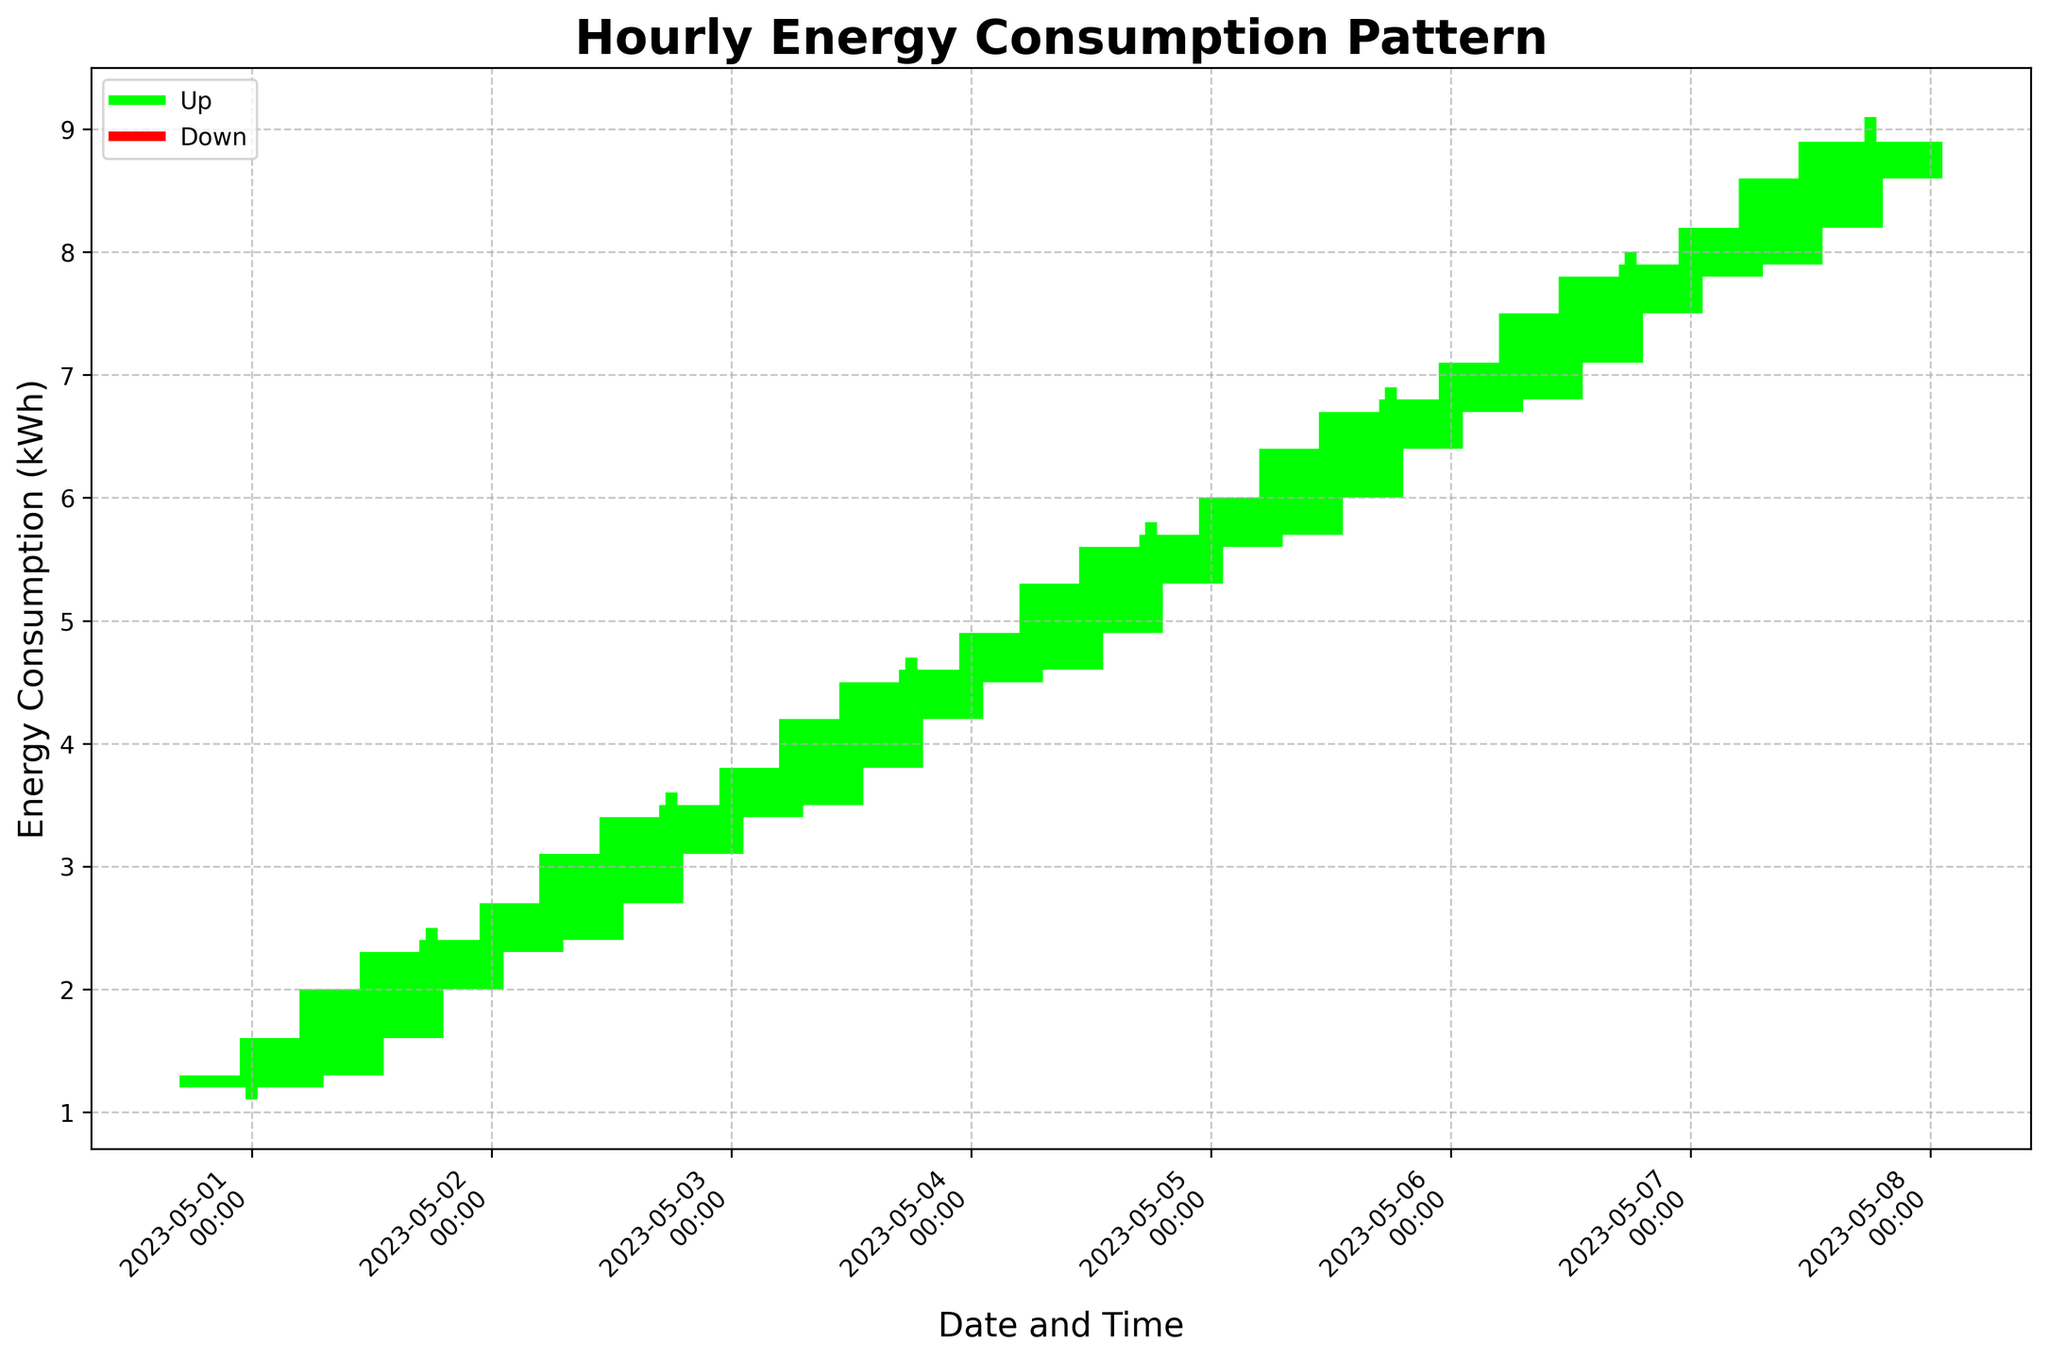What's the title of the figure? The title is usually located at the top of the plot. In this case, the title reads "Hourly Energy Consumption Pattern."
Answer: Hourly Energy Consumption Pattern What are the labels for the x-axis and y-axis? The x-axis label is located horizontally at the bottom beneath the x-axis, and the y-axis label is located vertically along the left side. For this figure, the x-axis is labeled "Date and Time," and the y-axis is labeled "Energy Consumption (kWh)."
Answer: Date and Time, Energy Consumption (kWh) Which color represents an upward trend in energy consumption? The plot uses green bars to indicate periods where the energy consumption closed higher than it opened.
Answer: Green On which date and time does the lowest recorded energy consumption in the dataset occur? By examining the low values on the plot and cross-referencing the x-axis, the lowest energy consumption of 1.1 kWh occurs on "2023-05-01 at 00:00."
Answer: 2023-05-01 00:00 How many times did energy consumption decrease from the open to the close within the week? By counting the number of red bars in the figure, we see that energy consumption decreased 0 times since there are no red bars.
Answer: 0 What is the average high value of energy consumption for each day? Sum up the high values for each "day" and divide by the number of entries per day, or count the data points for each day. For each day, the average is ( (1.5+1.8+2.2+2.5) / 4 ) for May 1st, ( (2.6+2.9+3.3+3.6) / 4 ) for May 2nd, and so forth.
Answer: [1.75, 3.10, 4.20, 5.30, 6.60, 7.70, 8.90] Which day's closing energy consumption consistently increases compared to the previous day? Comparing each day's closing value to the following day's opening value, we notice that from May 6th to May 7th, the energy consistently increased (6.8 < 6.7 < 7.9 < 7.8) during each period, May 6th having no increase
Answer: May 2nd What is the total increase in energy consumption from the opening of May 1 to the closing of May 7? First, find the opening value on May 1 (1.2 kWh) and the closing value on May 7 (8.9 kWh). The increase in energy consumption is the difference, (8.9 − 1.2) kWh
Answer: 7.7 Between what dates and hours was energy consumption the highest? Inspecting the high points visually, from May 7th 12:00 to May 7th 18:00, the maximum energy consumption was 8.8 to 9.1kWh
Answer: May 7 12:00, May 7 18:00 How does the energy consumption pattern change throughout a single day? Observing the figure, energy consumption generally increases during the day and peaks around 18:00. It dips around 00:00 and rises again from 06:00.
Answer: Increases during the day, peaks at 18:00, dips at 00:00, rises from 06:00 